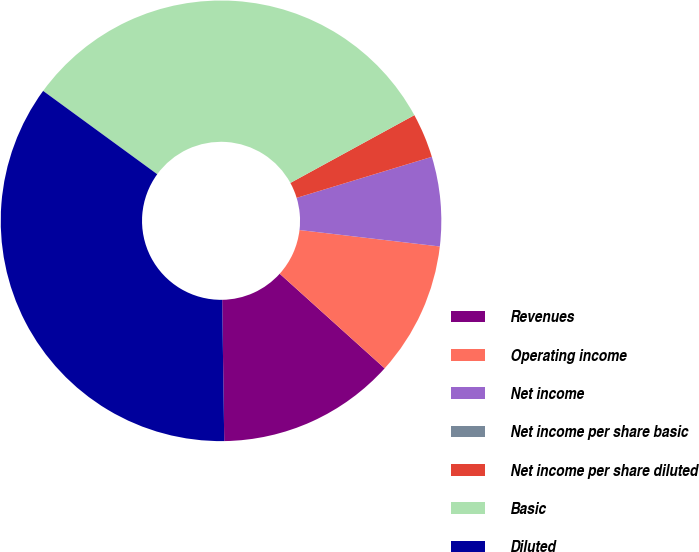Convert chart. <chart><loc_0><loc_0><loc_500><loc_500><pie_chart><fcel>Revenues<fcel>Operating income<fcel>Net income<fcel>Net income per share basic<fcel>Net income per share diluted<fcel>Basic<fcel>Diluted<nl><fcel>13.09%<fcel>9.82%<fcel>6.55%<fcel>0.0%<fcel>3.27%<fcel>32.0%<fcel>35.27%<nl></chart> 